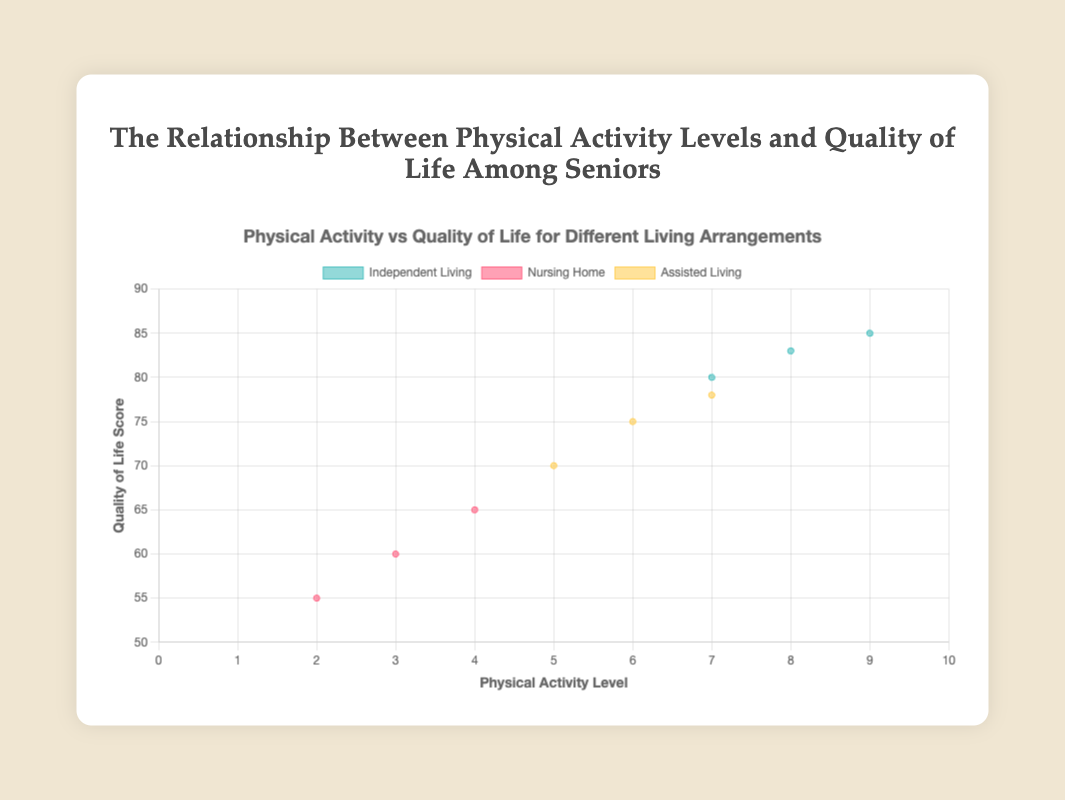How many data points are there in the "Nursing Home" living arrangement group? The dataset contains data points for different living arrangements, and the scatter plot would display these. By looking for data points in the color representing "Nursing Home," three can be identified.
Answer: 3 What is the general trend in the relationship between physical activity levels and quality of life scores in the scatter plot? The scatter plot’s trend can be observed by noting whether the data points form an upward or downward pattern. By visual inspection, higher physical activity levels generally correlate with higher quality of life scores across all living arrangements.
Answer: Higher physical activity, higher quality of life Which living arrangement group shows the highest individual quality of life score, and what is that score? The highest quality of life score can be identified by locating the uppermost data point on the y-axis. For "Independent Living," there is a data point at 85.
Answer: Independent Living, 85 Compare the average quality of life score between the "Independent Living" and "Nursing Home" groups. Calculate the average score by summing the scores of each group and then dividing by the count of data points. For "Independent Living," the scores are 80, 85, and 83, giving an average of (80 + 85 + 83) / 3 = 82.67. For "Nursing Home," the scores are 65, 60, and 55, giving an average of (65 + 60 + 55) / 3 = 60.
Answer: Independent Living: 82.67, Nursing Home: 60 Who has the lowest physical activity level, and what is their quality of life score? Locate the data point with the lowest x-value (physical activity level) and determine the corresponding y-value (quality of life score). Susan Martinez has a physical activity level of 2, with a quality of life score of 55.
Answer: Susan Martinez, 55 Is there a data point for "Assisted Living" with a physical activity level of 7? If yes, what is the quality of life score, and who is it for? Check the "Assisted Living" group for a data point with a physical activity level of 7. This data point has a corresponding quality of life score of 78, belonging to Steven Thompson.
Answer: Yes, 78, Steven Thompson What's the difference in quality of life scores between the highest and lowest physical activity levels within the "Nursing Home" group? For "Nursing Home," identify the highest and lowest physical activity levels: 4 (Jane Smith) and 2 (Susan Martinez). Subtract their quality of life scores (65 and 55). The difference is 65 - 55.
Answer: 10 Which living arrangement group shows the most variation in quality of life scores? To determine variation, compare the range (difference between highest and lowest scores) for each group. "Nursing Home" ranges from 55 to 65 (range: 10), "Assisted Living" ranges from 70 to 78 (range: 8), and "Independent Living" ranges from 80 to 85 (range: 5). Therefore, "Nursing Home" has the most variation.
Answer: Nursing Home 